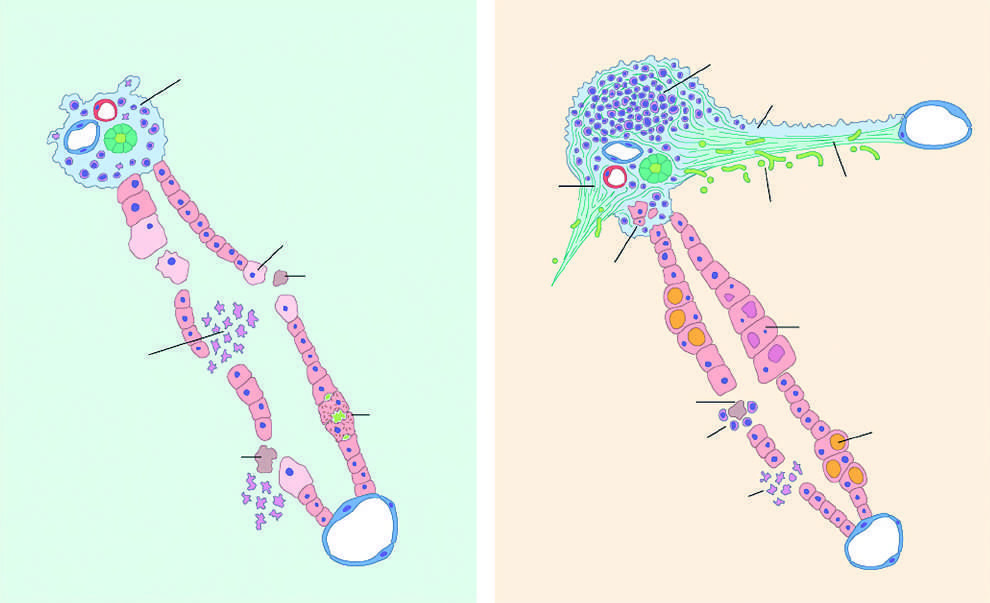re portal infiltrates dense and prominent?
Answer the question using a single word or phrase. Yes 